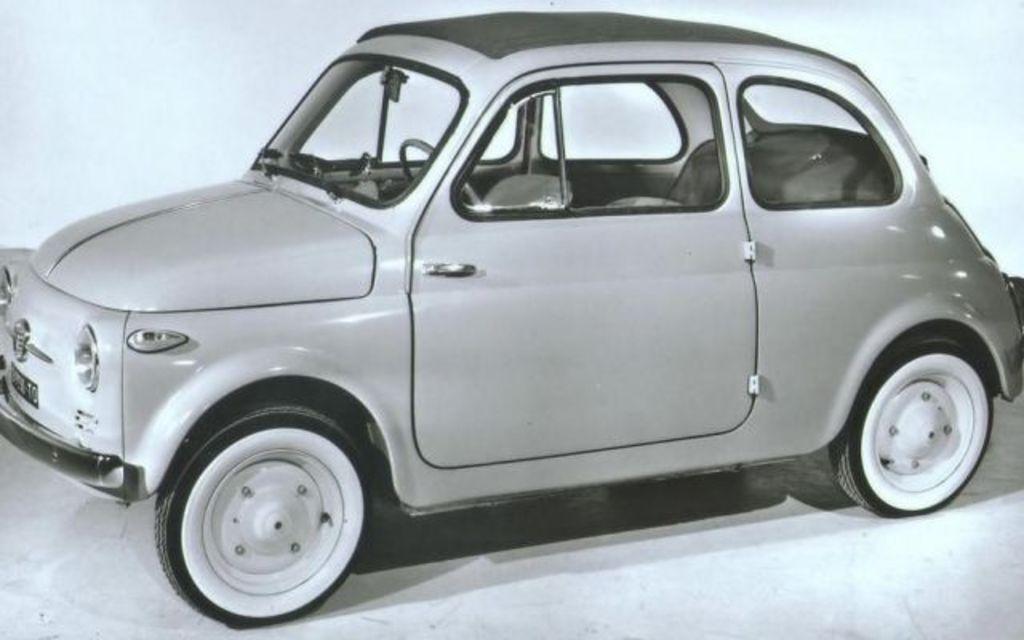In one or two sentences, can you explain what this image depicts? This image is black and white. In this image we can see a car. In the back there is a wall. 